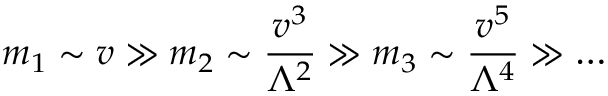<formula> <loc_0><loc_0><loc_500><loc_500>m _ { 1 } \sim v \gg m _ { 2 } \sim \frac { v ^ { 3 } } { \Lambda ^ { 2 } } \gg m _ { 3 } \sim \frac { v ^ { 5 } } { \Lambda ^ { 4 } } \gg \dots</formula> 